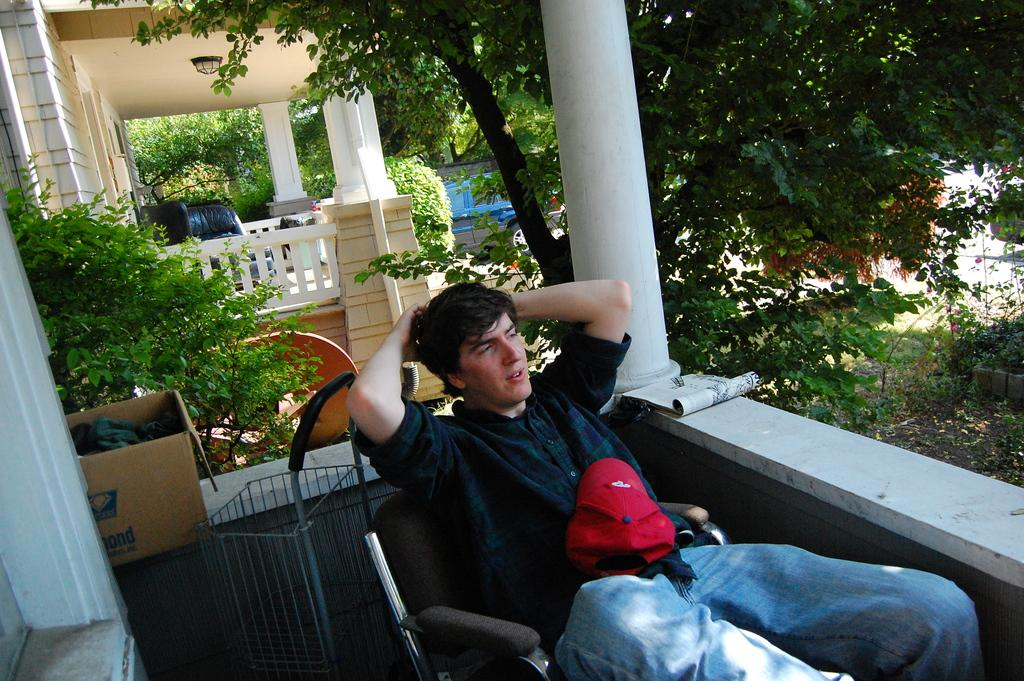Who is the person in the image? There is a man in the image. What is the man doing in the image? The man is sitting on a chair in the image. Where is the man located in relation to the buildings? The man is under a building in the image. What can be seen behind the man? There are trees behind the man, and another building can be seen behind the trees. What type of humor can be seen in the man's facial expression in the image? There is no indication of humor or any specific facial expression in the image; it simply shows a man sitting on a chair. 